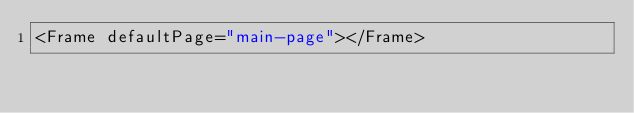<code> <loc_0><loc_0><loc_500><loc_500><_XML_><Frame defaultPage="main-page"></Frame></code> 